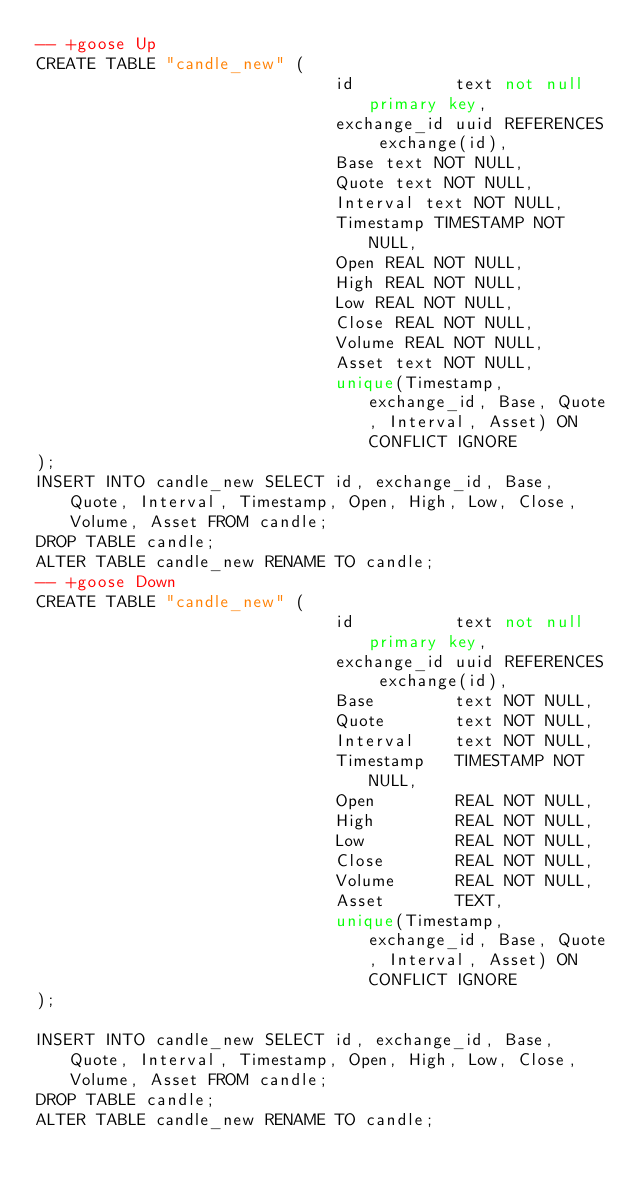<code> <loc_0><loc_0><loc_500><loc_500><_SQL_>-- +goose Up
CREATE TABLE "candle_new" (
                              id	        text not null primary key,
                              exchange_id uuid REFERENCES exchange(id),
                              Base text NOT NULL,
                              Quote text NOT NULL,
                              Interval text NOT NULL,
                              Timestamp TIMESTAMP NOT NULL,
                              Open REAL NOT NULL,
                              High REAL NOT NULL,
                              Low REAL NOT NULL,
                              Close REAL NOT NULL,
                              Volume REAL NOT NULL,
                              Asset text NOT NULL,
                              unique(Timestamp, exchange_id, Base, Quote, Interval, Asset) ON CONFLICT IGNORE
);
INSERT INTO candle_new SELECT id, exchange_id, Base, Quote, Interval, Timestamp, Open, High, Low, Close, Volume, Asset FROM candle;
DROP TABLE candle;
ALTER TABLE candle_new RENAME TO candle;
-- +goose Down
CREATE TABLE "candle_new" (
                              id	        text not null primary key,
                              exchange_id uuid REFERENCES exchange(id),
                              Base        text NOT NULL,
                              Quote       text NOT NULL,
                              Interval    text NOT NULL,
                              Timestamp   TIMESTAMP NOT NULL,
                              Open        REAL NOT NULL,
                              High        REAL NOT NULL,
                              Low         REAL NOT NULL,
                              Close       REAL NOT NULL,
                              Volume      REAL NOT NULL,
                              Asset       TEXT,
                              unique(Timestamp, exchange_id, Base, Quote, Interval, Asset) ON CONFLICT IGNORE
);

INSERT INTO candle_new SELECT id, exchange_id, Base, Quote, Interval, Timestamp, Open, High, Low, Close, Volume, Asset FROM candle;
DROP TABLE candle;
ALTER TABLE candle_new RENAME TO candle;
</code> 